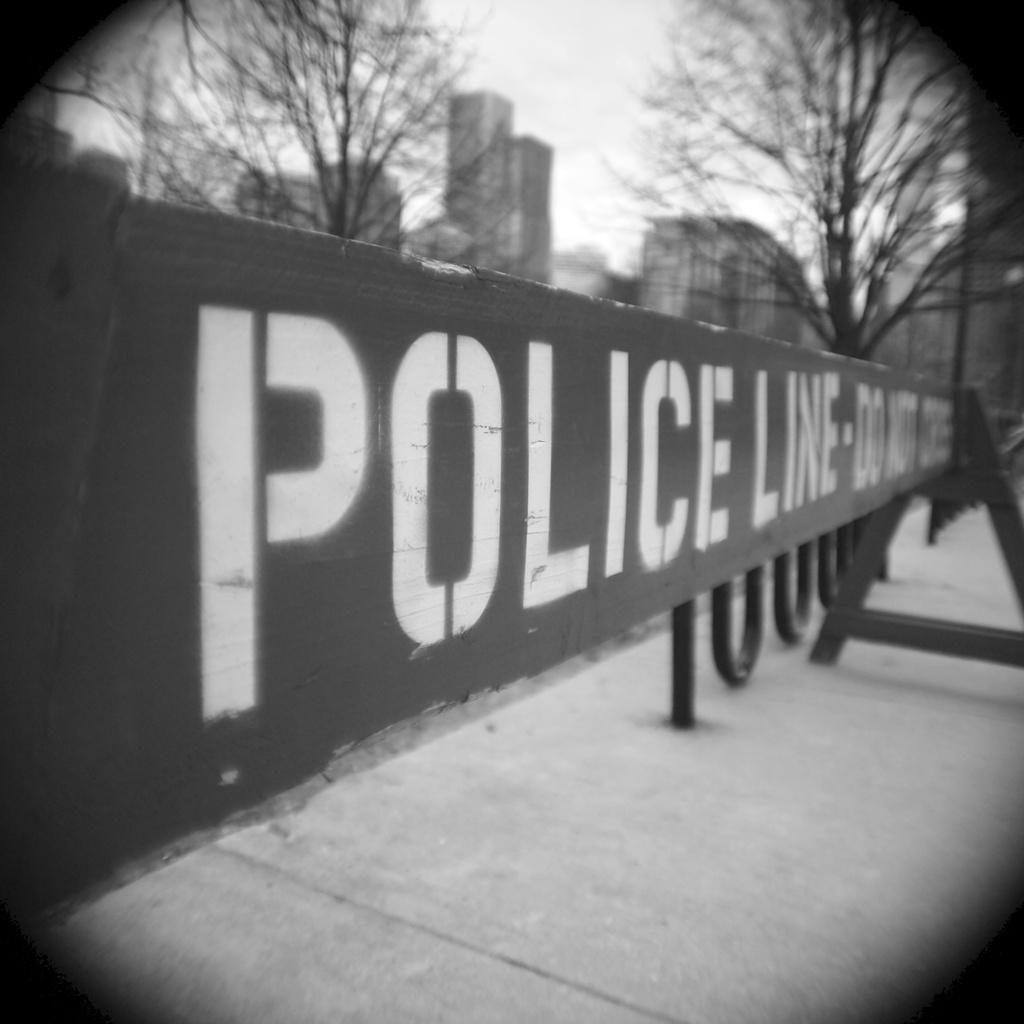What is the main subject in the image? There is a police line in the image. What type of natural vegetation can be seen in the image? There are trees visible in the image. What type of man-made structures can be seen in the image? There are buildings visible in the image. How many knives are visible in the image? There are no knives present in the image. Are there any pencils visible in the image? There are no pencils present in the image. Can you see any spiders in the image? There are no spiders present in the image. 